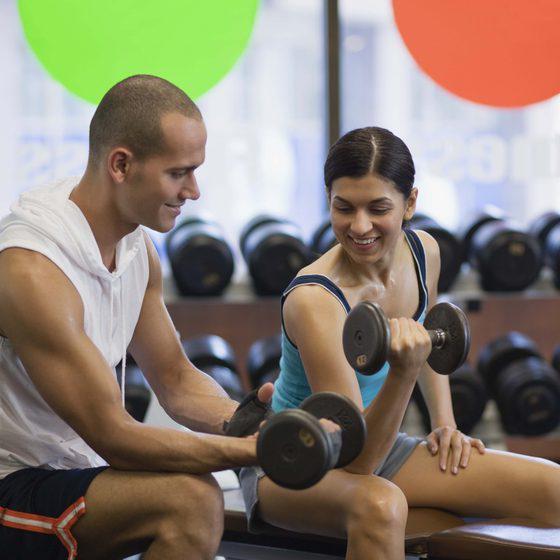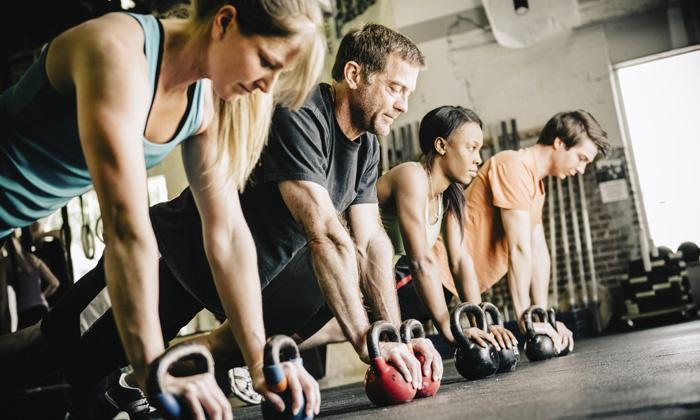The first image is the image on the left, the second image is the image on the right. For the images shown, is this caption "A person is holding a weight above their head." true? Answer yes or no. No. 